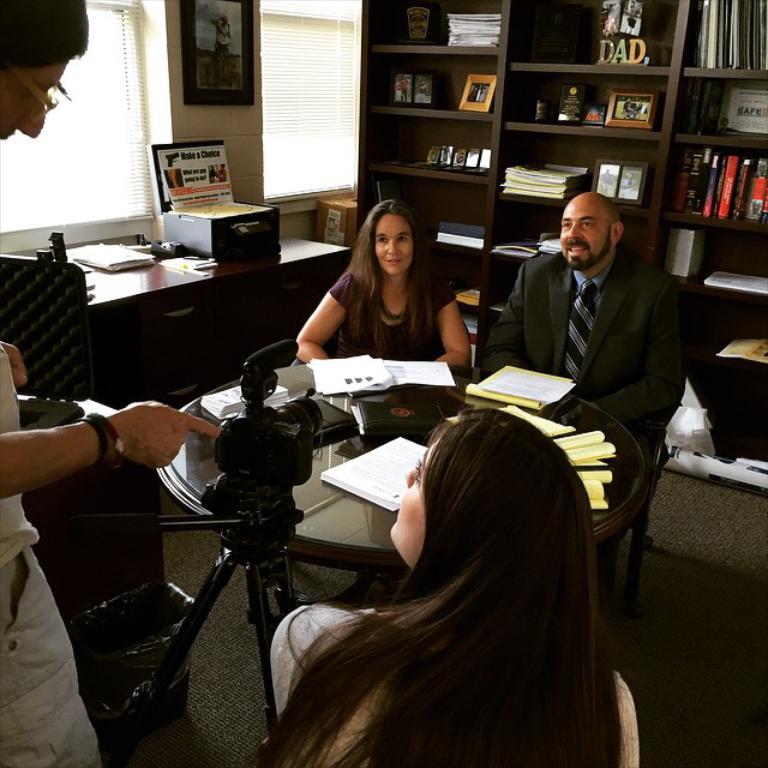What does the wooden letters on the bookcase spell?
Provide a short and direct response. Dad. 